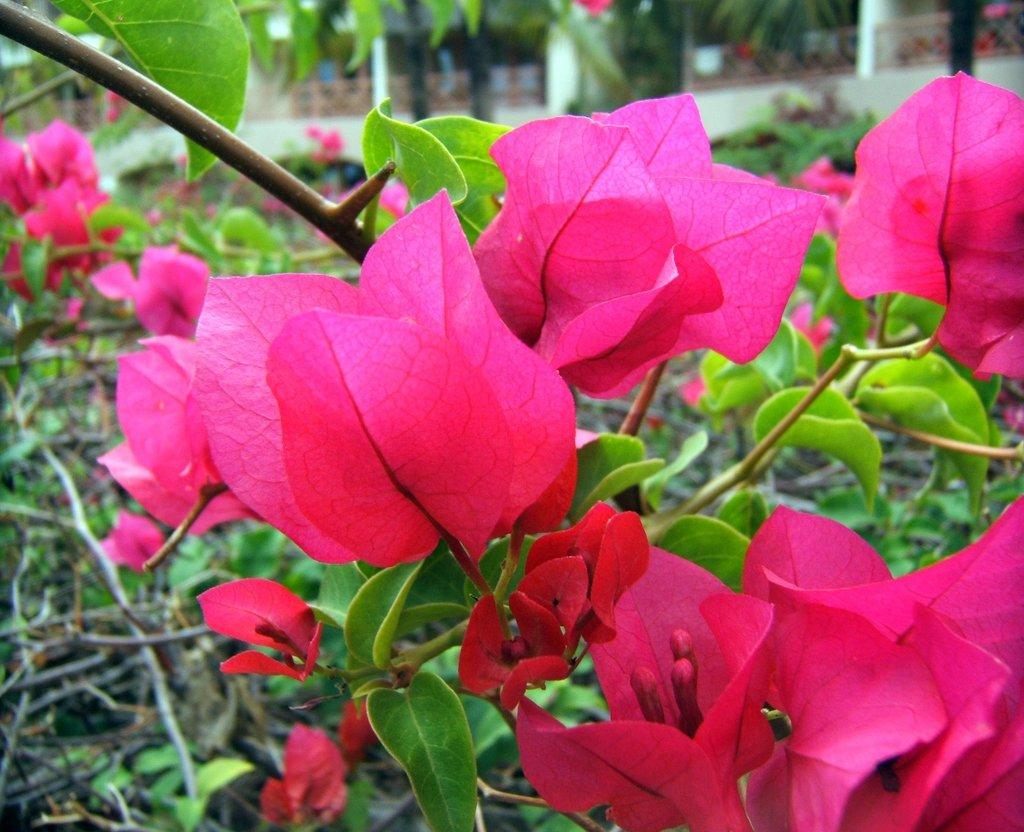What type of plants can be seen in the image? There are flowers in the image, which are associated with plants. Can you describe the setting in which the flowers are located? The flowers are located in a setting with a house visible in the background. What architectural feature is associated with the house? There is a fence associated with the house. What type of plastic material is used to create the flowers in the image? There is no indication in the image that the flowers are made of plastic; they appear to be real flowers. How does the wealth of the house owner affect the appearance of the flowers in the image? The image does not provide any information about the wealth of the house owner, so it cannot be determined how it might affect the appearance of the flowers. 